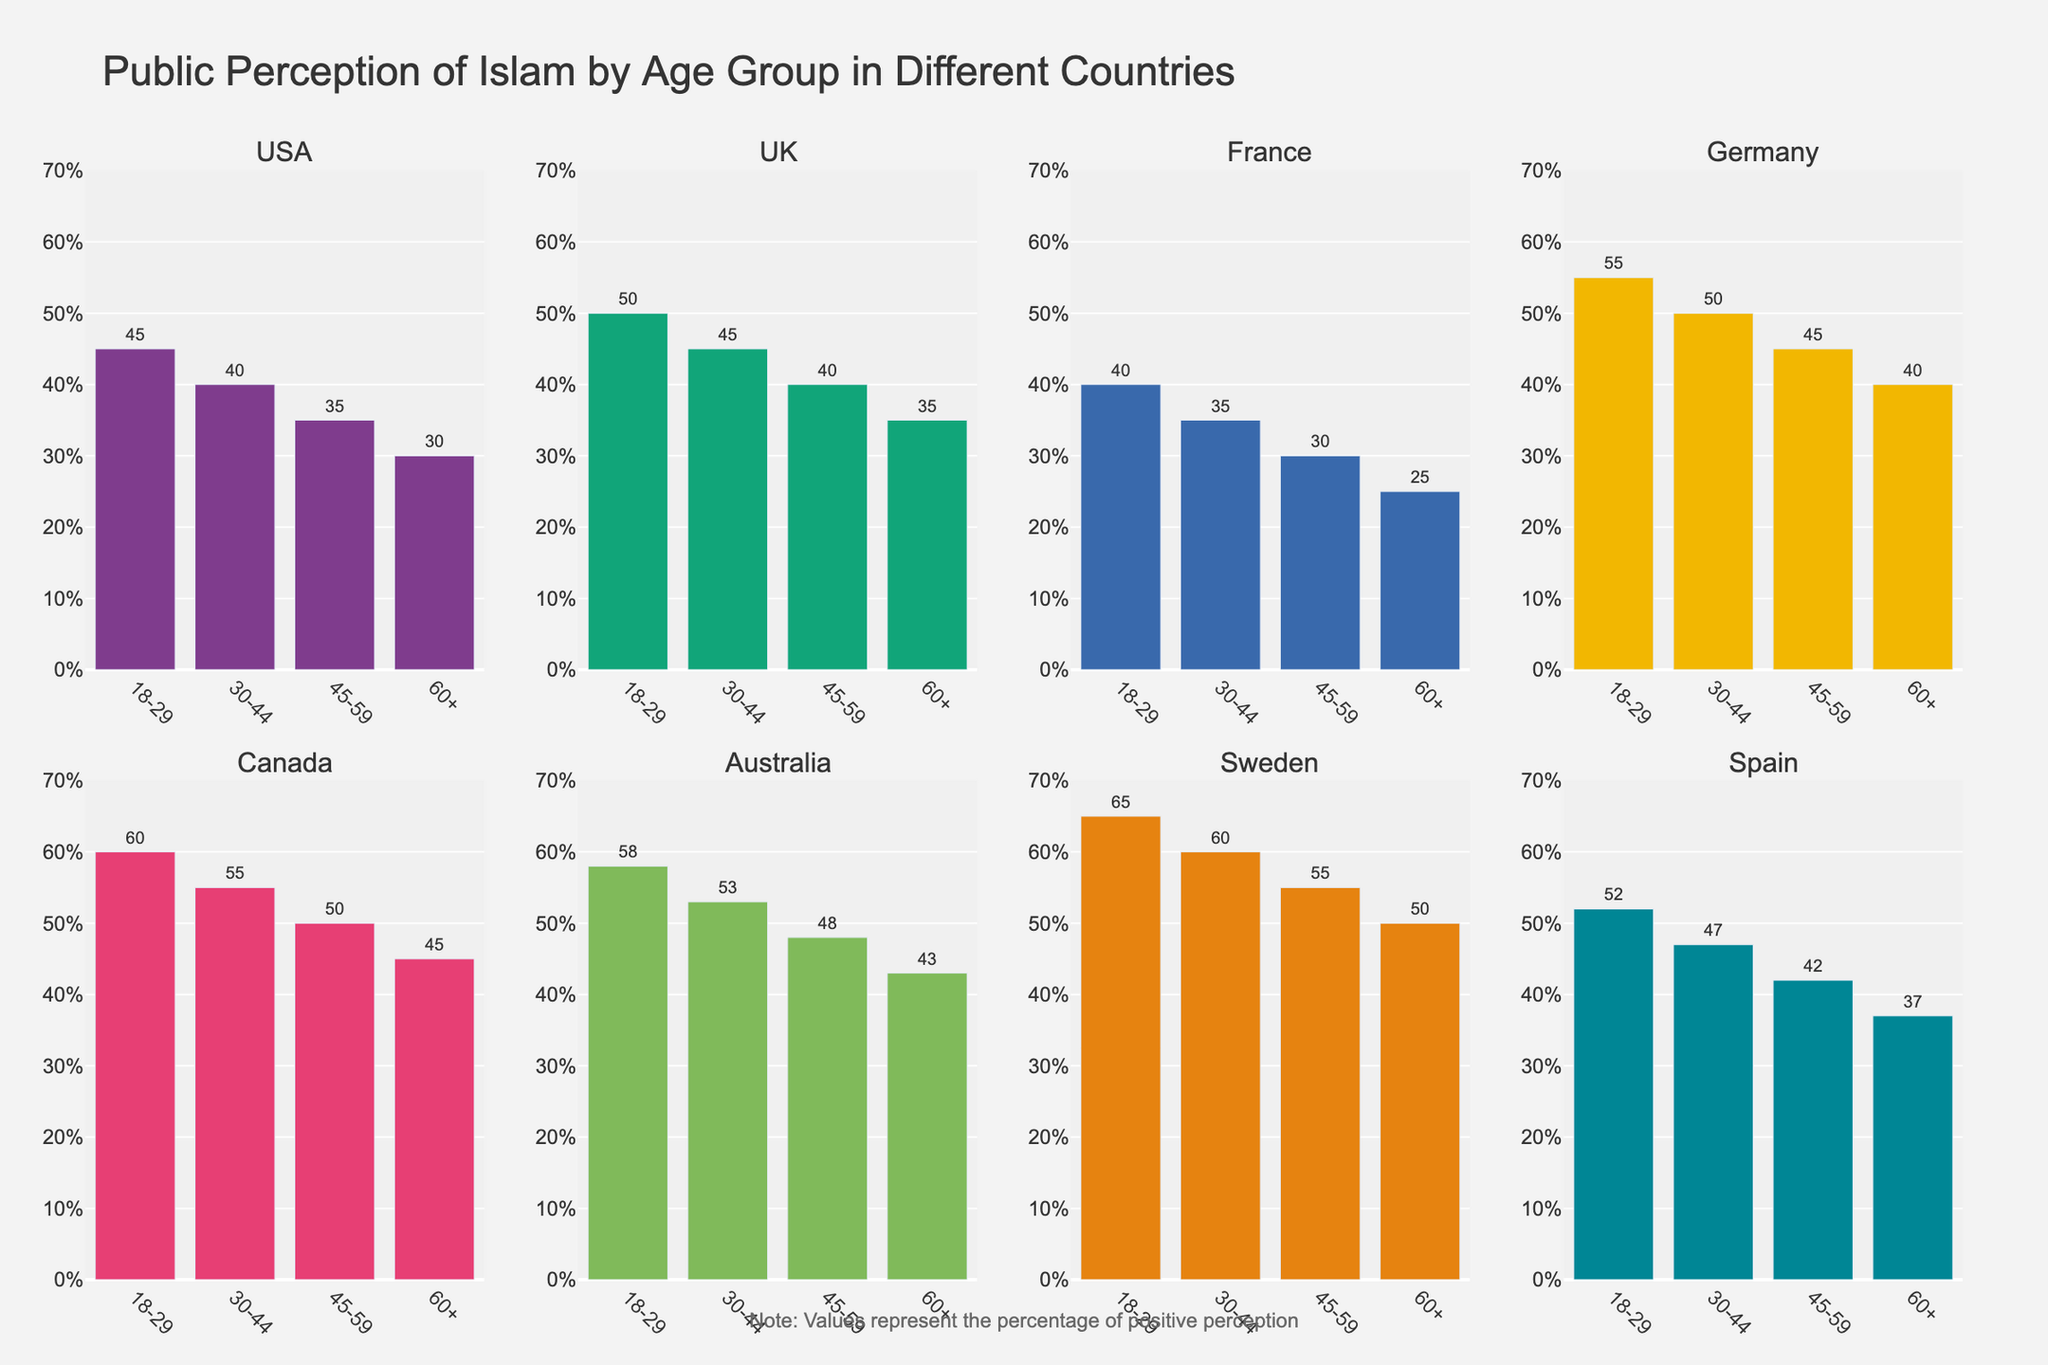Which country has the highest positive perception of Islam in the 18-29 age group? The highest bar in the 18-29 age group across all countries will indicate the country with the highest positive perception. Sweden has the tallest bar for this age group, showing 65%.
Answer: Sweden Which age group in the USA has the lowest positive perception of Islam? Comparing the heights of the bars for each age group in the USA subplot, the 60+ age group has the shortest bar, indicating 30%.
Answer: 60+ What is the average positive perception of Islam across all age groups in the UK? Sum the percentages for all age groups in the UK (50+45+40+35) and divide by the number of age groups (4). (50+45+40+35) / 4 = 42.5
Answer: 42.5 Is the positive perception of Islam in Germany for the 30-44 age group higher or lower than that in Canada for the same age group? Compare the heights of the bars for the 30-44 age group in the Germany and Canada subplots. Germany's bar shows 50%, and Canada's shows 55%.
Answer: Lower Which country shows the largest difference in positive perception of Islam between the 18-29 and 60+ age groups? Calculate the difference for each country: USA (45-30=15), UK (50-35=15), France (40-25=15), Germany (55-40=15), Canada (60-45=15), Australia (58-43=15), Sweden (65-50=15), Spain (52-37=15). All countries have a difference of 15%.
Answer: All countries have the same difference: 15 What is the range of positive perception percentages in France across all age groups? Identify the highest and lowest bars in the France subplot: 18-29 (40) and 60+ (25). Range = 40 - 25 = 15
Answer: 15 Does any age group in Australia have a positive perception percentage lower than the highest positive perception percentage in the USA? The highest positive perception in the USA is 45% (18-29 group). Compare this with all age groups in Australia, where 60+ shows 43%, which is the lowest but still higher than 45%.
Answer: No Which country has the most consistent positive perception of Islam across all age groups? The consistency can be seen by comparing the bar heights across age groups within a country. Canada shows a small decrease (60, 55, 50, 45), indicating relatively consistent values.
Answer: Canada In Spain, which two consecutive age groups have the smallest difference in positive perception percentages? Calculate the differences between consecutive age groups: 18-29 minus 30-44 (52-47=5), 30-44 minus 45-59 (47-42=5), 45-59 minus 60+ (42-37=5). All differences are the same (5).
Answer: All consecutive groups have the same difference: 5 Which country has the highest positive perception of Islam in the 45-59 age group? The tallest bar in the 45-59 age group across all countries indicates the highest positive perception. Sweden has the tallest bar with 55%.
Answer: Sweden 